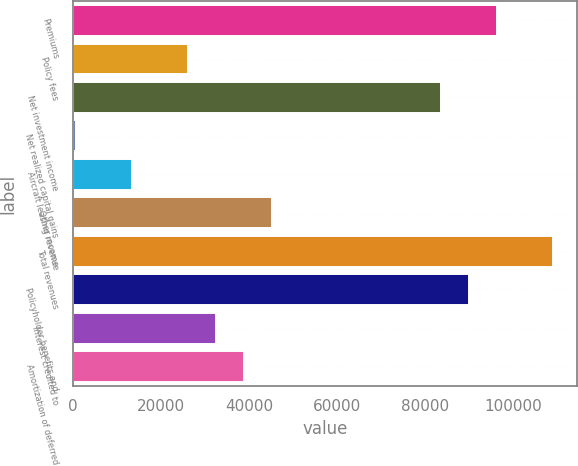<chart> <loc_0><loc_0><loc_500><loc_500><bar_chart><fcel>Premiums<fcel>Policy fees<fcel>Net investment income<fcel>Net realized capital gains<fcel>Aircraft leasing revenue<fcel>Other income<fcel>Total revenues<fcel>Policyholder benefits and<fcel>Interest credited to<fcel>Amortization of deferred<nl><fcel>96239.5<fcel>26205.8<fcel>83506.1<fcel>739<fcel>13472.4<fcel>45305.9<fcel>108973<fcel>89872.8<fcel>32572.5<fcel>38939.2<nl></chart> 